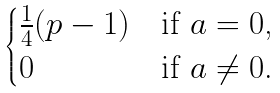Convert formula to latex. <formula><loc_0><loc_0><loc_500><loc_500>\begin{cases} \frac { 1 } { 4 } ( p - 1 ) & \text {if $a=0$,} \\ 0 & \text {if $a \ne 0$.} \end{cases}</formula> 